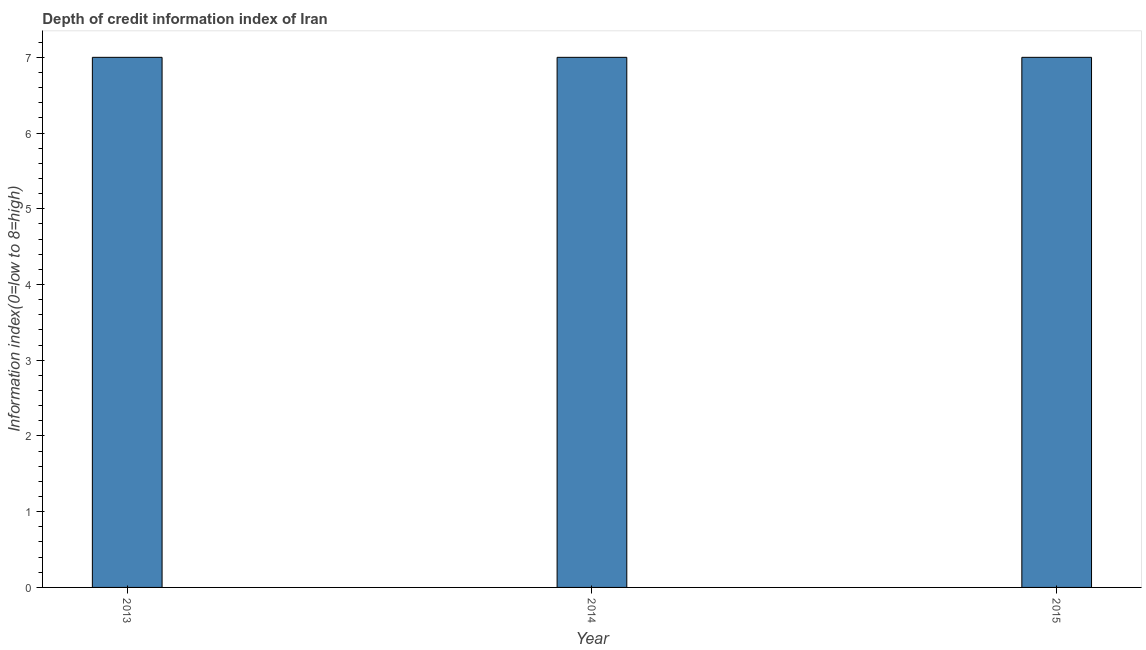Does the graph contain any zero values?
Your answer should be very brief. No. What is the title of the graph?
Your answer should be very brief. Depth of credit information index of Iran. What is the label or title of the X-axis?
Ensure brevity in your answer.  Year. What is the label or title of the Y-axis?
Provide a succinct answer. Information index(0=low to 8=high). What is the depth of credit information index in 2014?
Your response must be concise. 7. Across all years, what is the maximum depth of credit information index?
Offer a terse response. 7. In which year was the depth of credit information index maximum?
Your response must be concise. 2013. In which year was the depth of credit information index minimum?
Provide a short and direct response. 2013. What is the sum of the depth of credit information index?
Provide a short and direct response. 21. Do a majority of the years between 2015 and 2014 (inclusive) have depth of credit information index greater than 5 ?
Keep it short and to the point. No. Is the depth of credit information index in 2013 less than that in 2014?
Your answer should be very brief. No. What is the difference between the highest and the lowest depth of credit information index?
Ensure brevity in your answer.  0. How many bars are there?
Keep it short and to the point. 3. Are all the bars in the graph horizontal?
Offer a very short reply. No. How many years are there in the graph?
Ensure brevity in your answer.  3. Are the values on the major ticks of Y-axis written in scientific E-notation?
Give a very brief answer. No. What is the Information index(0=low to 8=high) in 2014?
Your answer should be very brief. 7. What is the Information index(0=low to 8=high) in 2015?
Ensure brevity in your answer.  7. What is the difference between the Information index(0=low to 8=high) in 2013 and 2015?
Make the answer very short. 0. What is the difference between the Information index(0=low to 8=high) in 2014 and 2015?
Your answer should be compact. 0. What is the ratio of the Information index(0=low to 8=high) in 2013 to that in 2014?
Keep it short and to the point. 1. What is the ratio of the Information index(0=low to 8=high) in 2013 to that in 2015?
Provide a succinct answer. 1. What is the ratio of the Information index(0=low to 8=high) in 2014 to that in 2015?
Provide a short and direct response. 1. 